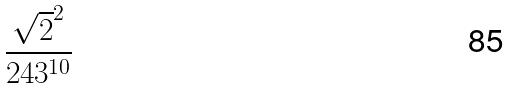<formula> <loc_0><loc_0><loc_500><loc_500>\frac { \sqrt { 2 } ^ { 2 } } { 2 4 3 ^ { 1 0 } }</formula> 